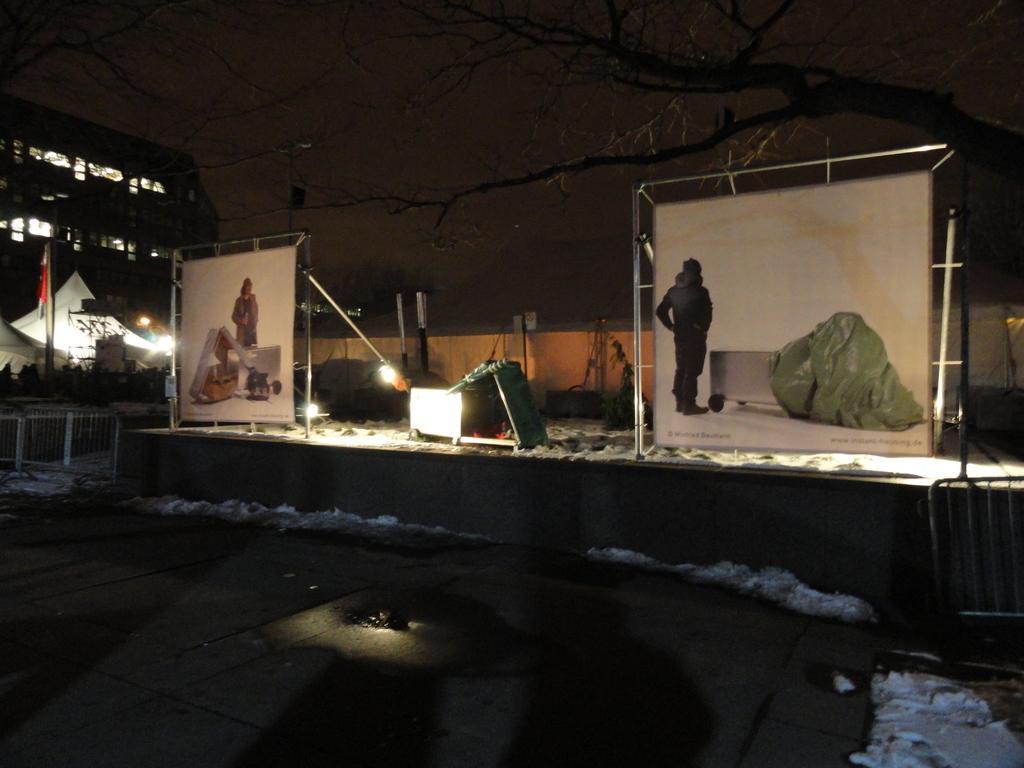In one or two sentences, can you explain what this image depicts? In this picture there are two banners which has a picture on it is attached to an object and there is an object in between it and there is a tree in the right top corner and there is a building and some other objects in left corner. 